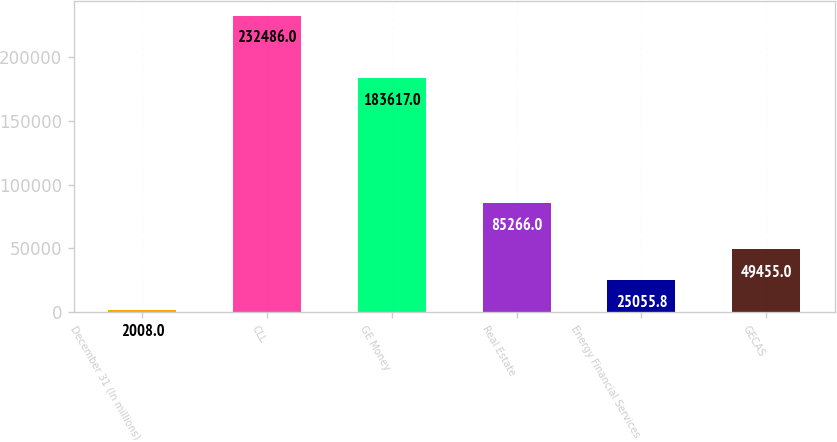Convert chart to OTSL. <chart><loc_0><loc_0><loc_500><loc_500><bar_chart><fcel>December 31 (In millions)<fcel>CLL<fcel>GE Money<fcel>Real Estate<fcel>Energy Financial Services<fcel>GECAS<nl><fcel>2008<fcel>232486<fcel>183617<fcel>85266<fcel>25055.8<fcel>49455<nl></chart> 